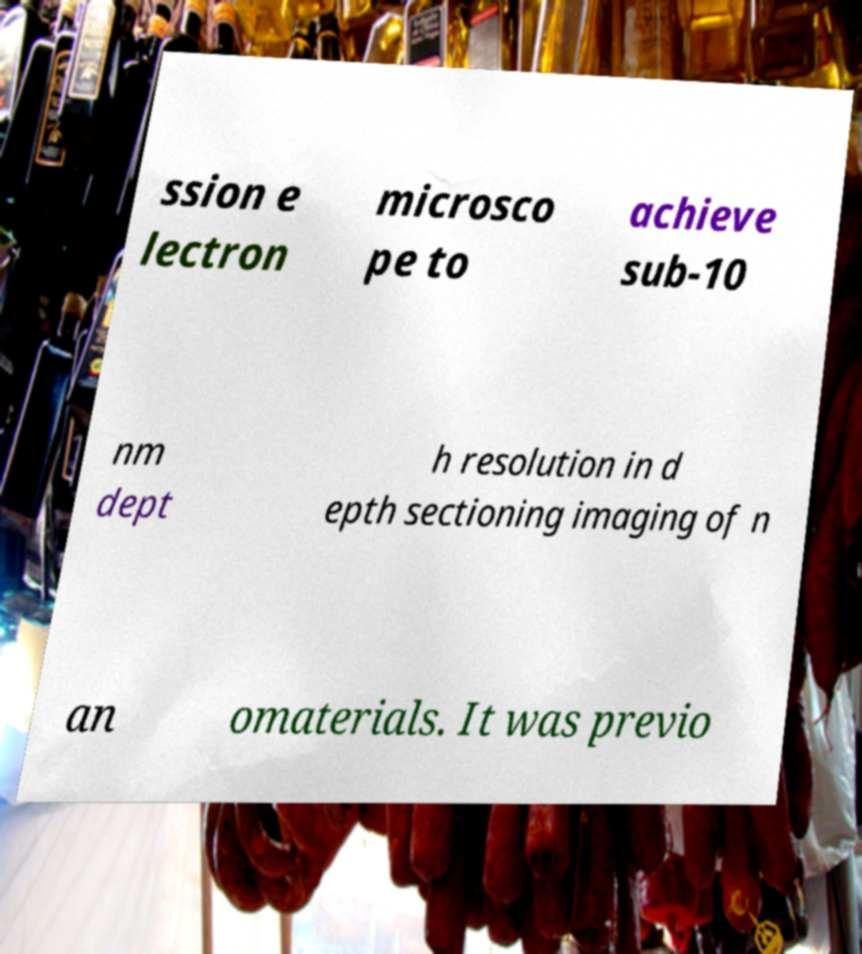Can you read and provide the text displayed in the image?This photo seems to have some interesting text. Can you extract and type it out for me? ssion e lectron microsco pe to achieve sub-10 nm dept h resolution in d epth sectioning imaging of n an omaterials. It was previo 